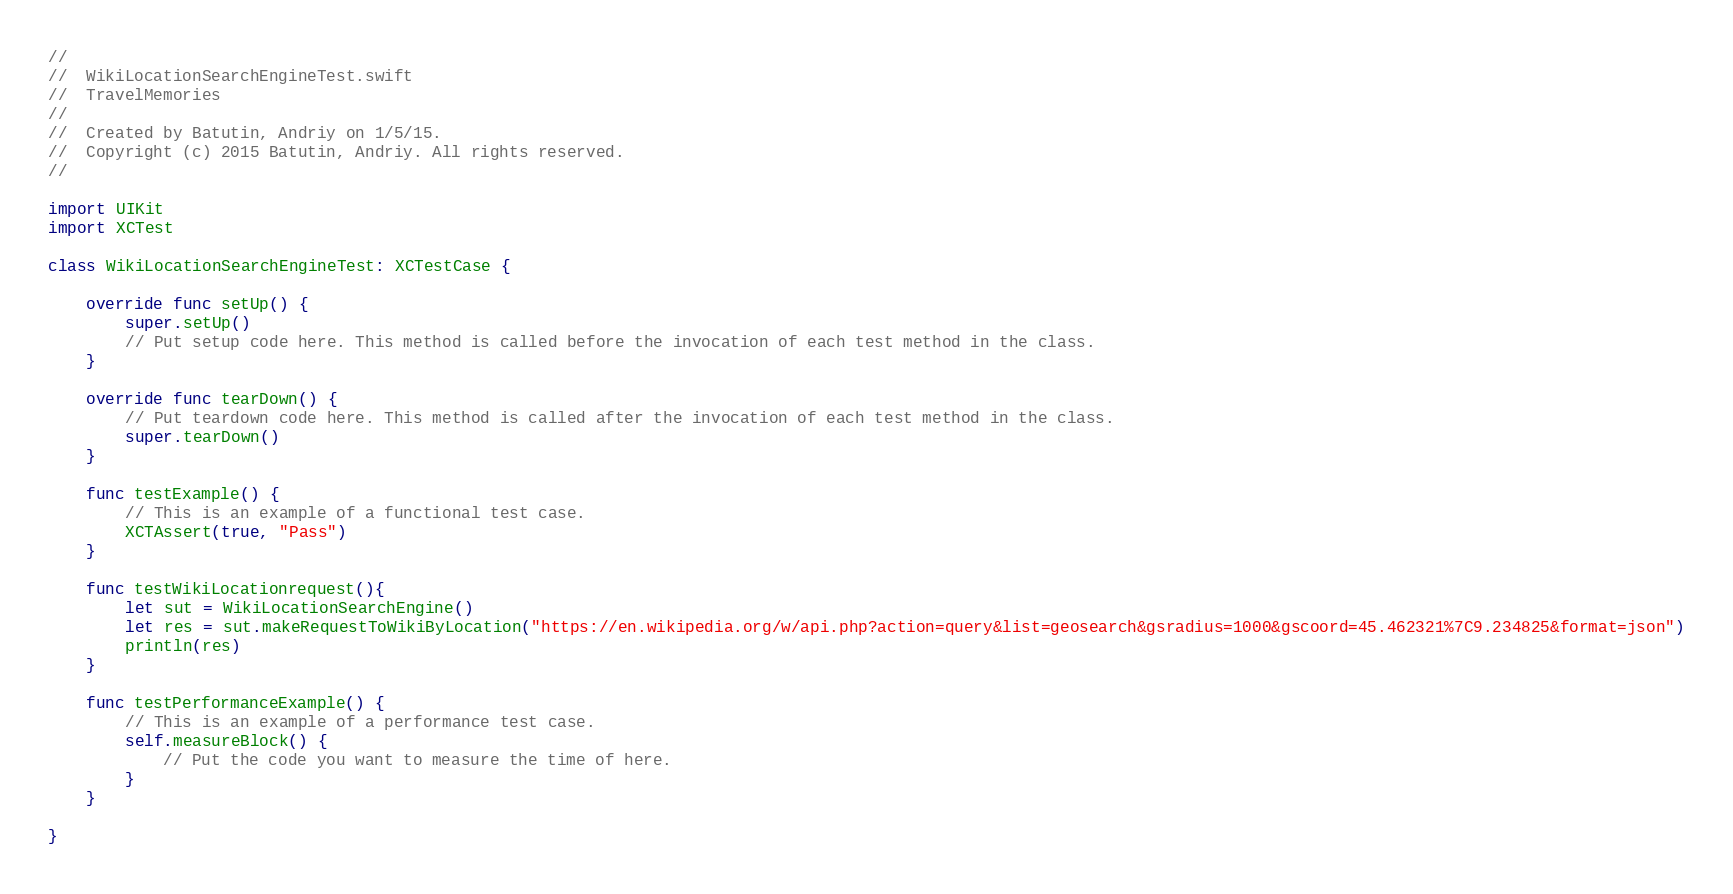Convert code to text. <code><loc_0><loc_0><loc_500><loc_500><_Swift_>//
//  WikiLocationSearchEngineTest.swift
//  TravelMemories
//
//  Created by Batutin, Andriy on 1/5/15.
//  Copyright (c) 2015 Batutin, Andriy. All rights reserved.
//

import UIKit
import XCTest

class WikiLocationSearchEngineTest: XCTestCase {
    
    override func setUp() {
        super.setUp()
        // Put setup code here. This method is called before the invocation of each test method in the class.
    }
    
    override func tearDown() {
        // Put teardown code here. This method is called after the invocation of each test method in the class.
        super.tearDown()
    }
    
    func testExample() {
        // This is an example of a functional test case.
        XCTAssert(true, "Pass")
    }
    
    func testWikiLocationrequest(){
        let sut = WikiLocationSearchEngine()
        let res = sut.makeRequestToWikiByLocation("https://en.wikipedia.org/w/api.php?action=query&list=geosearch&gsradius=1000&gscoord=45.462321%7C9.234825&format=json")
        println(res)
    }
    
    func testPerformanceExample() {
        // This is an example of a performance test case.
        self.measureBlock() {
            // Put the code you want to measure the time of here.
        }
    }
    
}</code> 